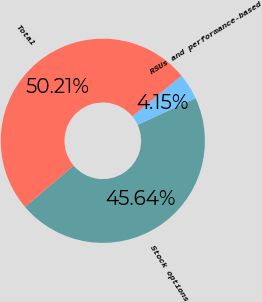Convert chart. <chart><loc_0><loc_0><loc_500><loc_500><pie_chart><fcel>Stock options<fcel>RSUs and performance-based<fcel>Total<nl><fcel>45.64%<fcel>4.15%<fcel>50.21%<nl></chart> 